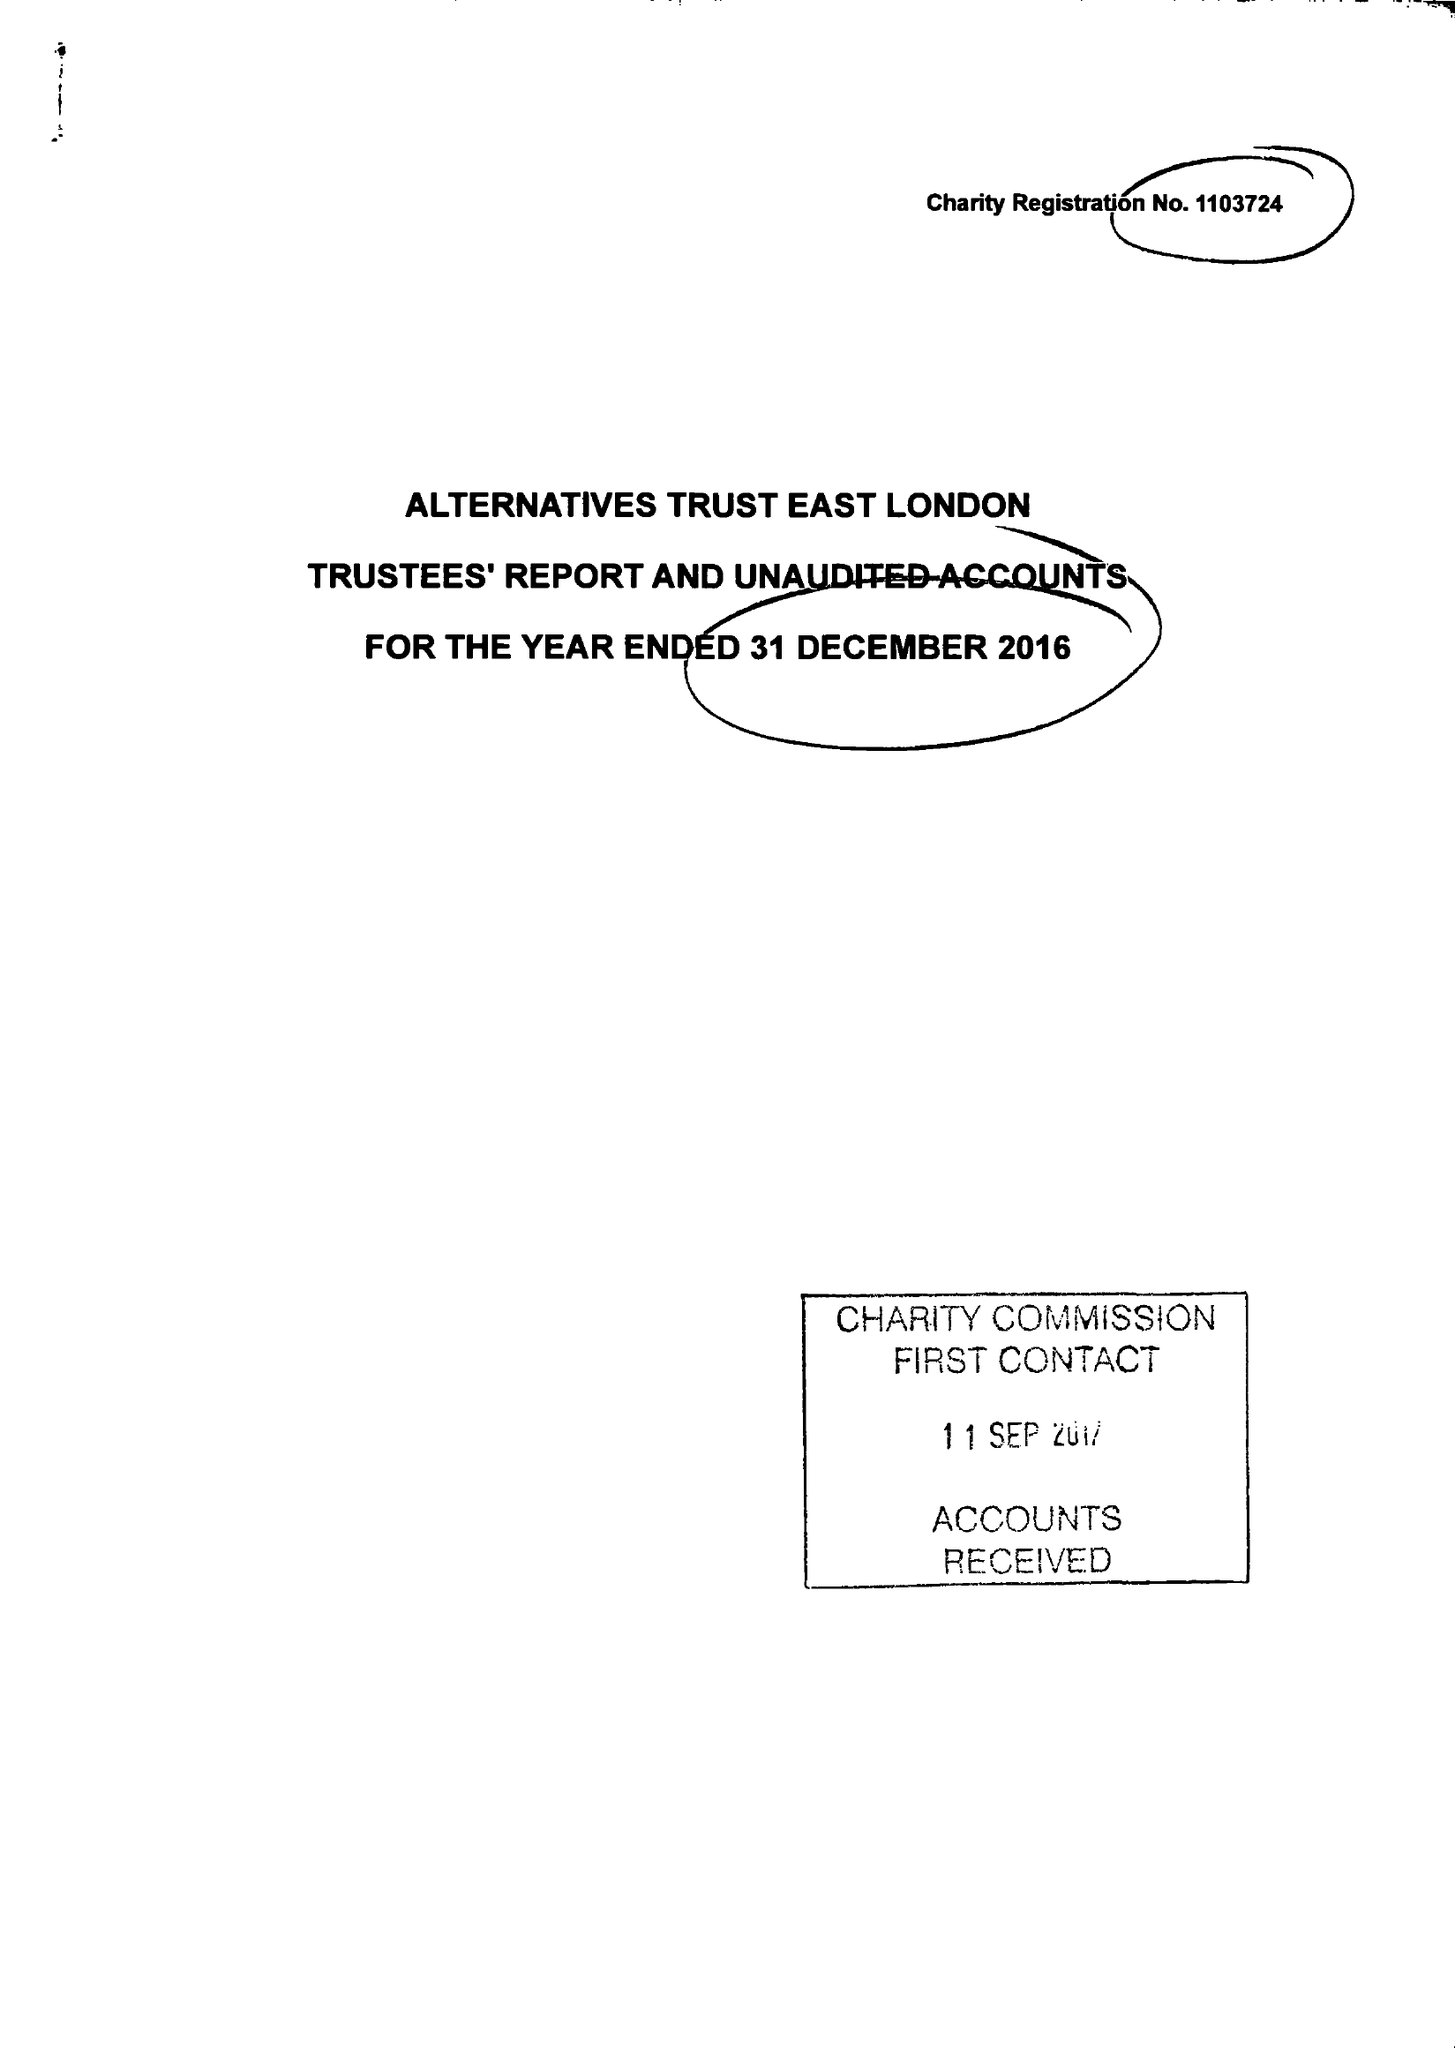What is the value for the address__street_line?
Answer the question using a single word or phrase. 63 ROWNTREE CLIFFORD CLOSE 